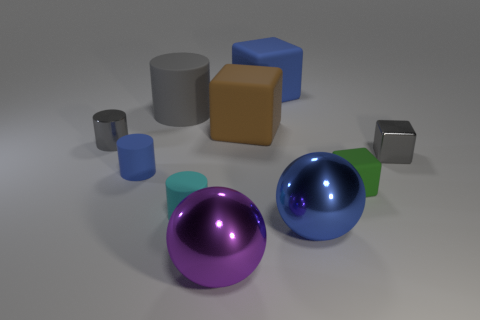Subtract all cyan cylinders. How many cylinders are left? 3 Subtract all small gray metallic blocks. How many blocks are left? 3 Subtract 2 cylinders. How many cylinders are left? 2 Subtract all blue blocks. Subtract all green spheres. How many blocks are left? 3 Subtract all spheres. How many objects are left? 8 Subtract all red balls. How many brown cubes are left? 1 Subtract all red rubber balls. Subtract all tiny cyan matte cylinders. How many objects are left? 9 Add 3 large brown cubes. How many large brown cubes are left? 4 Add 6 brown metal objects. How many brown metal objects exist? 6 Subtract 0 red cylinders. How many objects are left? 10 